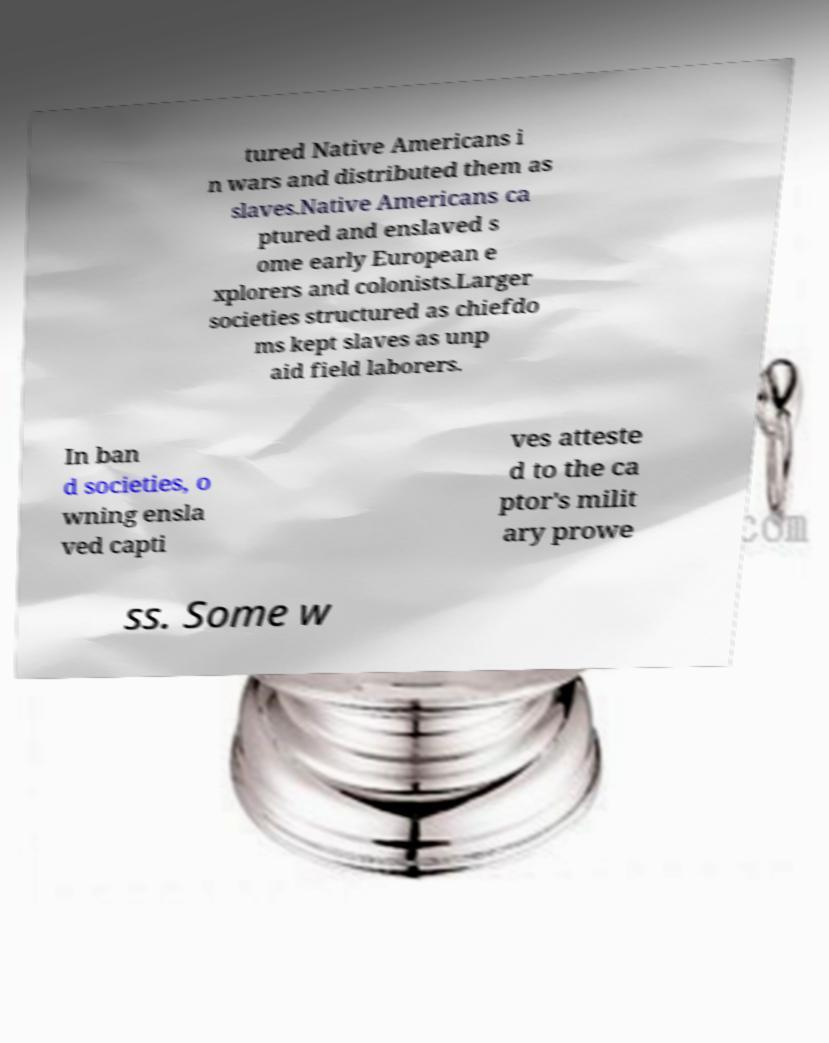What messages or text are displayed in this image? I need them in a readable, typed format. tured Native Americans i n wars and distributed them as slaves.Native Americans ca ptured and enslaved s ome early European e xplorers and colonists.Larger societies structured as chiefdo ms kept slaves as unp aid field laborers. In ban d societies, o wning ensla ved capti ves atteste d to the ca ptor's milit ary prowe ss. Some w 